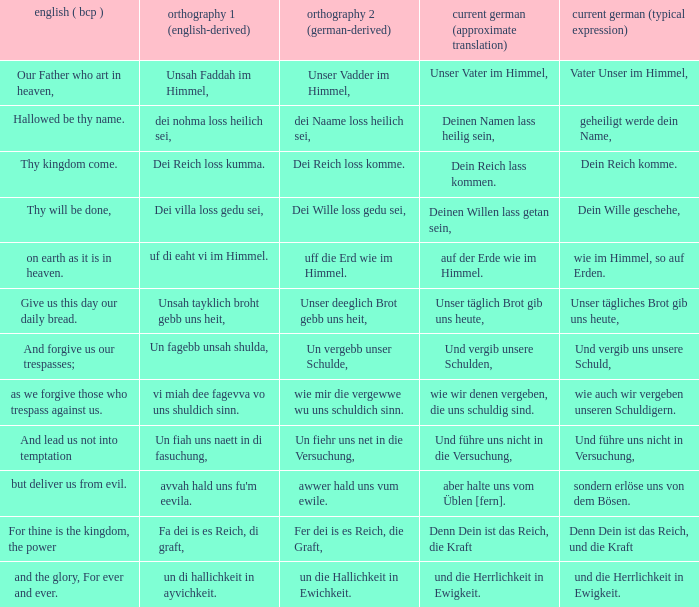What is the english (bcp) phrase "for thine is the kingdom, the power" in modern german with standard wording? Denn Dein ist das Reich, und die Kraft. 